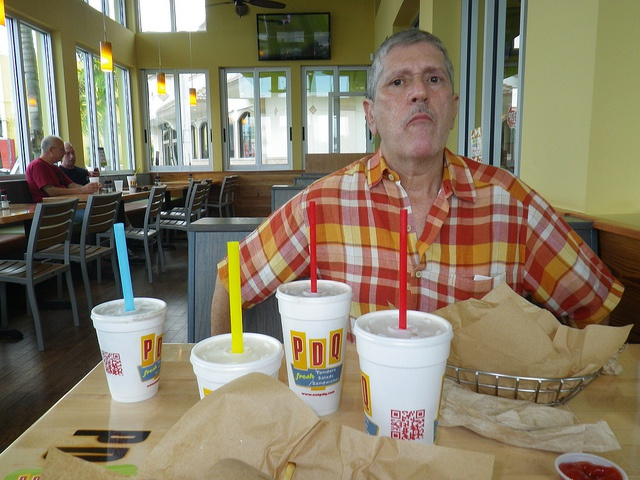Describe the objects in this image and their specific colors. I can see dining table in gold, tan, darkgray, lightgray, and gray tones, people in gold, gray, brown, darkgray, and tan tones, cup in gold, lightgray, darkgray, and brown tones, cup in gold, lightgray, darkgray, orange, and gray tones, and cup in gold, lightgray, darkgray, and brown tones in this image. 